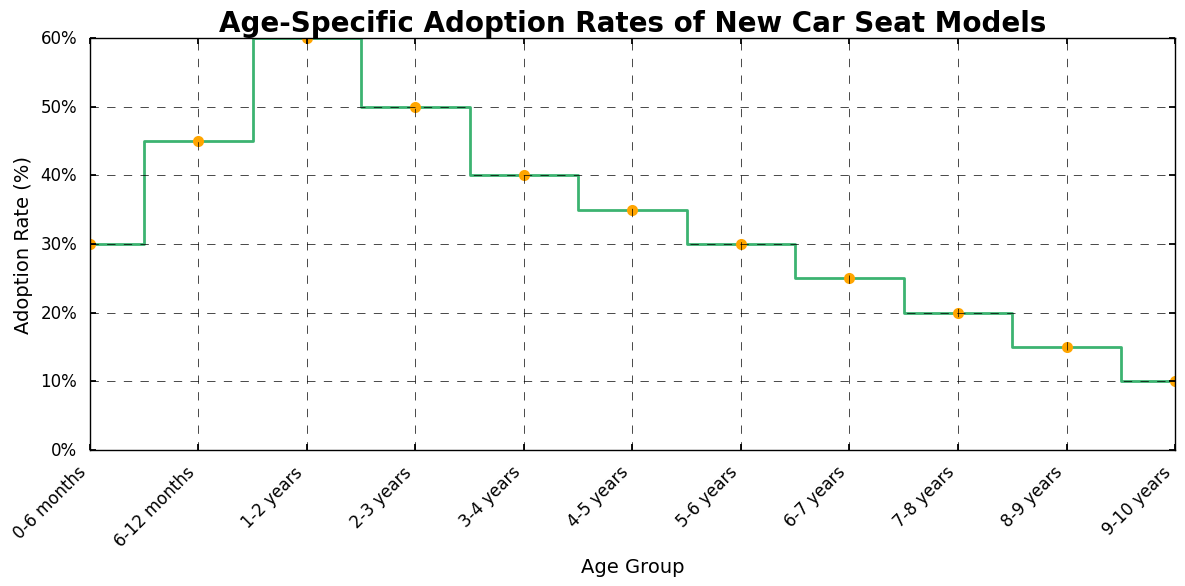Which age group has the highest adoption rate of new car seat models? The figure shows varying adoption rates across different age groups. By examining the plot, we observe that the highest adoption rate is 60% for the 1-2 years age group.
Answer: 1-2 years What is the overall trend in adoption rates as age increases from 0-6 months to 9-10 years? The plot illustrates a general decline in adoption rates as the age increases. Initially, the rates increase, peaking at 1-2 years, then gradually decrease as age continues to rise.
Answer: Decreasing trend Which two consecutive age groups have the largest difference in adoption rates? By looking at the differences between each consecutive age group, we see that the largest drop occurs between 1-2 years (60%) and 2-3 years (50%) with a 10% difference.
Answer: 1-2 years and 2-3 years What is the sum of the adoption rates for age groups 3-4 years and 4-5 years? The figure shows that the adoption rates are 40% for 3-4 years and 35% for 4-5 years. Summing these up, we get 40% + 35% = 75%.
Answer: 75% What is the average adoption rate for children aged 2-5 years? The adoption rates for the age groups 2-3 years, 3-4 years, and 4-5 years are 50%, 40%, and 35%, respectively. The average is calculated as (50 + 40 + 35) / 3 = 125 / 3 = approximately 41.67%.
Answer: 41.67% Which color is used for the markers in the plot? The plot uses orange for the markers, which is visually distinct and enhances the clarity of the data points.
Answer: Orange Does the adoption rate ever plateau or remain the same across consecutive age groups? By examining the plot, we can see that for each consecutive age group, the adoption rate changes. There is no age group pair with the same adoption rate.
Answer: No How much does the adoption rate decrease between age group 6-7 years and 8-9 years? The adoption rates for 6-7 years and 8-9 years are 25% and 15%, respectively. The decrease is 25% - 15% = 10%.
Answer: 10% 